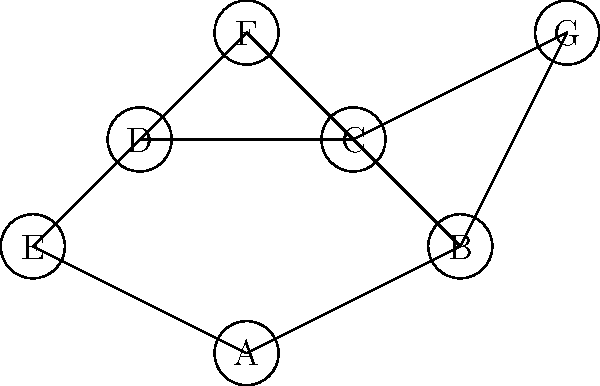In a network of stamp collectors, each node represents a collector, and edges represent connections through which rare stamps can be traded. Given the graph above, what is the minimum number of collectors that need to be removed to disconnect collector F from collector G? To solve this problem, we need to find the minimum number of node-disjoint paths between F and G. This is equivalent to finding the minimum vertex cut between F and G.

Step 1: Identify all paths between F and G:
1. F - C - G
2. F - C - B - G
3. F - D - C - G
4. F - D - C - B - G
5. F - D - A - B - G

Step 2: Analyze the paths:
- All paths go through either C or D.
- There are no paths that avoid both C and D.

Step 3: Determine the minimum vertex cut:
- Removing both C and D will disconnect F from G.
- Removing only C or only D is not sufficient, as there will still be a path between F and G.

Step 4: Verify that there is no smaller cut:
- There is no single node that, when removed, disconnects F from G.

Therefore, the minimum number of collectors that need to be removed to disconnect F from G is 2.
Answer: 2 